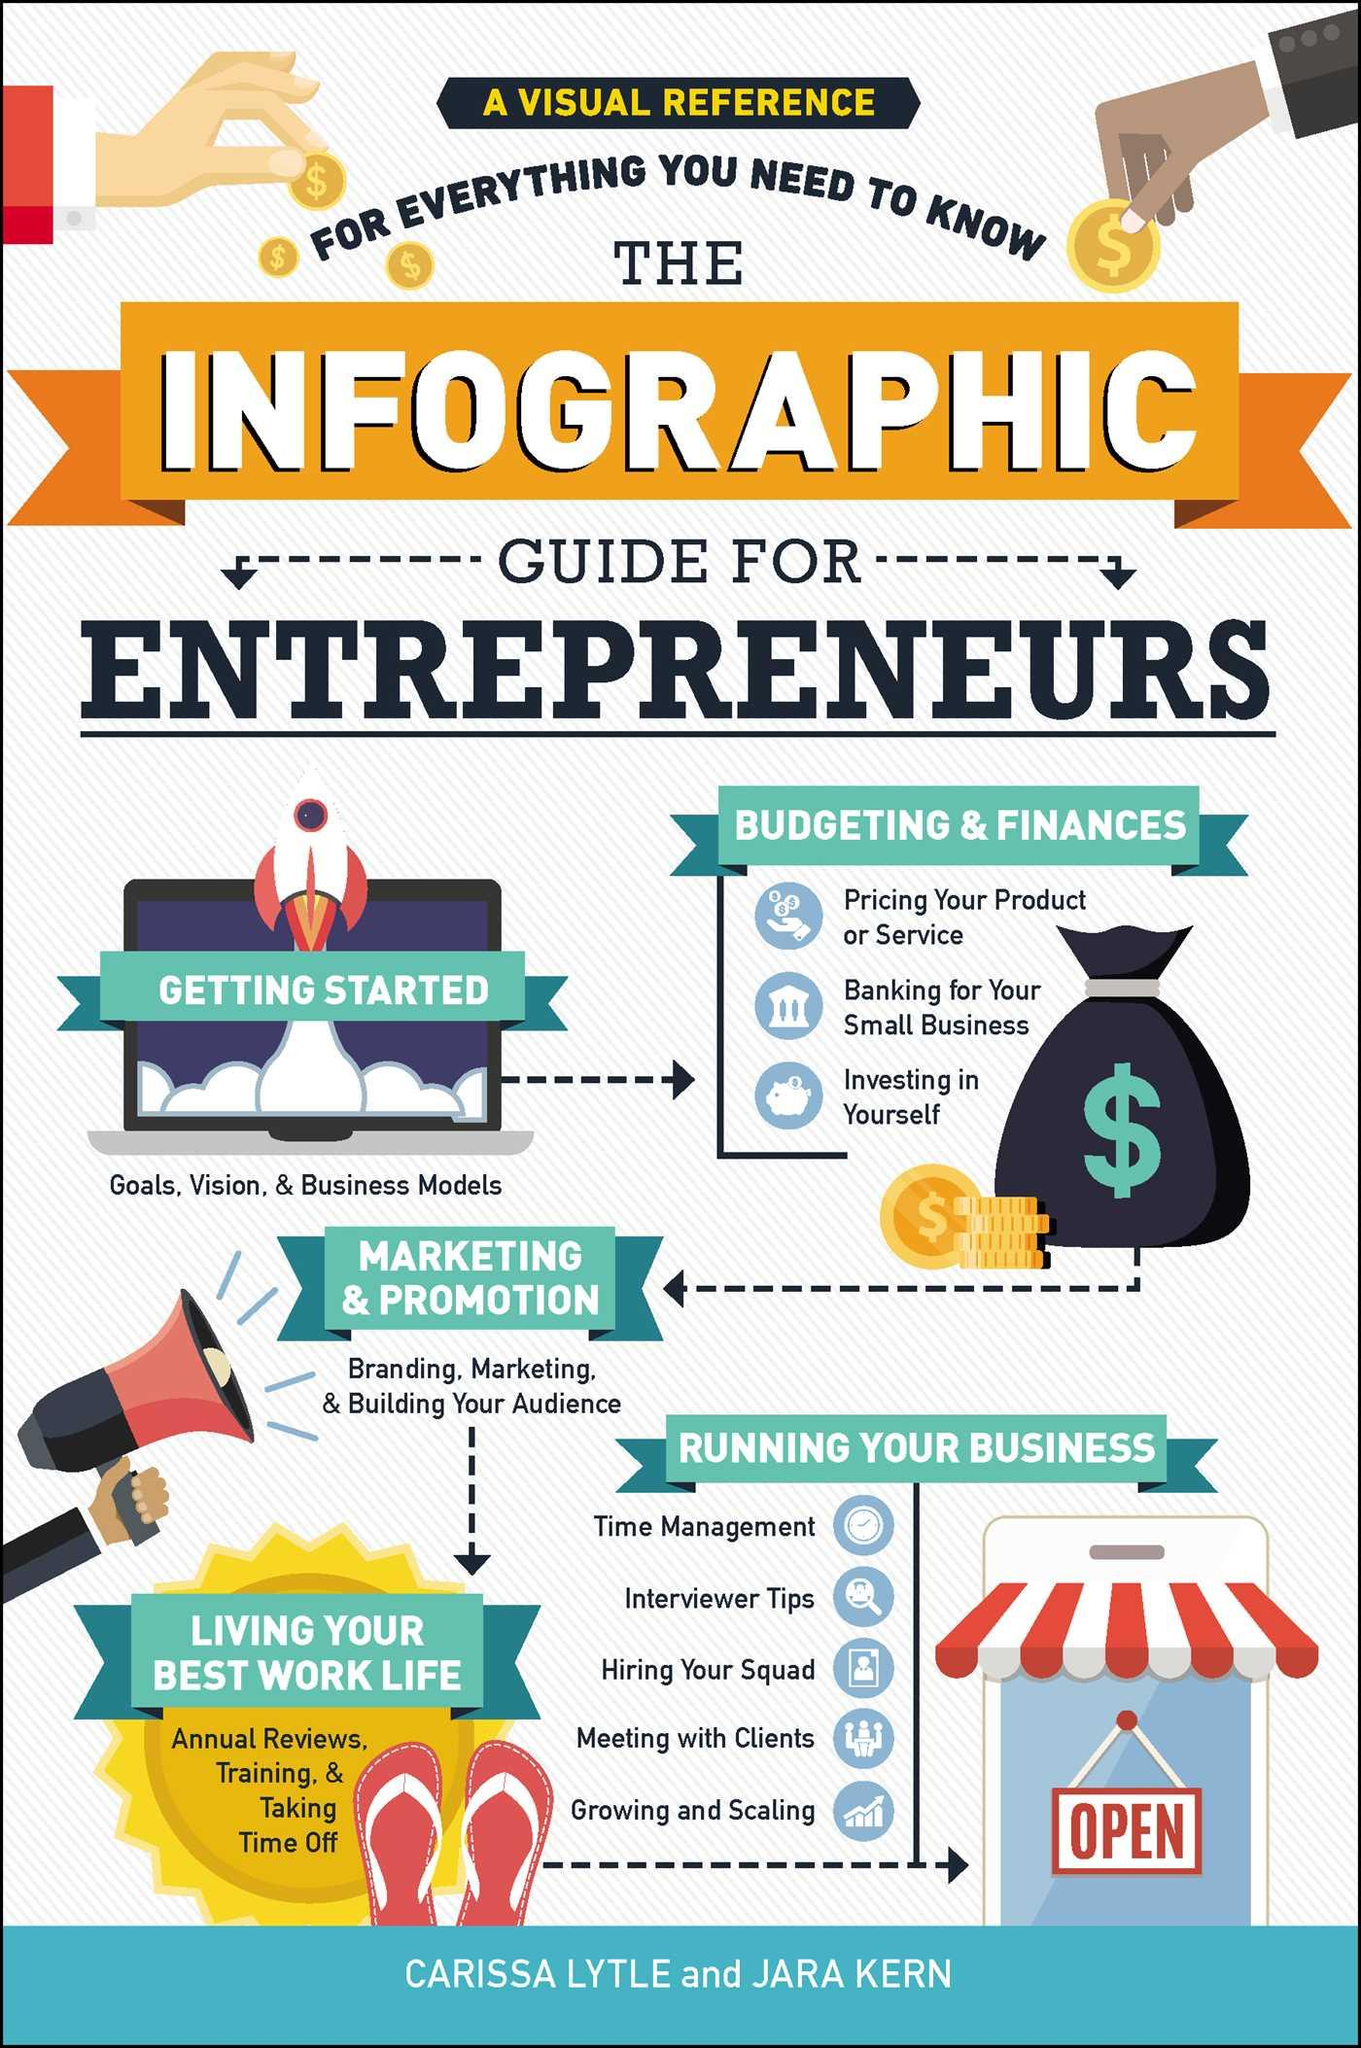Give some essential details in this illustration. Five steps should be followed as a guide for entrepreneurs. 